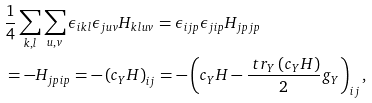Convert formula to latex. <formula><loc_0><loc_0><loc_500><loc_500>& \frac { 1 } { 4 } \sum _ { k , l } \sum _ { u , v } \epsilon _ { i k l } \epsilon _ { j u v } H _ { k l u v } = \epsilon _ { i j p } \epsilon _ { j i p } H _ { j p j p } \\ & = - H _ { j p i p } = - \left ( c _ { Y } H \right ) _ { i j } = - \left ( c _ { Y } H - \frac { \ t r _ { Y } \left ( c _ { Y } H \right ) } { 2 } g _ { Y } \right ) _ { i j } ,</formula> 